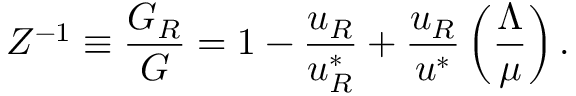<formula> <loc_0><loc_0><loc_500><loc_500>Z ^ { - 1 } \equiv \frac { G _ { R } } { G } = 1 - \frac { u _ { R } } { u _ { R } ^ { * } } + \frac { u _ { R } } { u ^ { * } } \left ( \frac { \Lambda } { \mu } \right ) .</formula> 